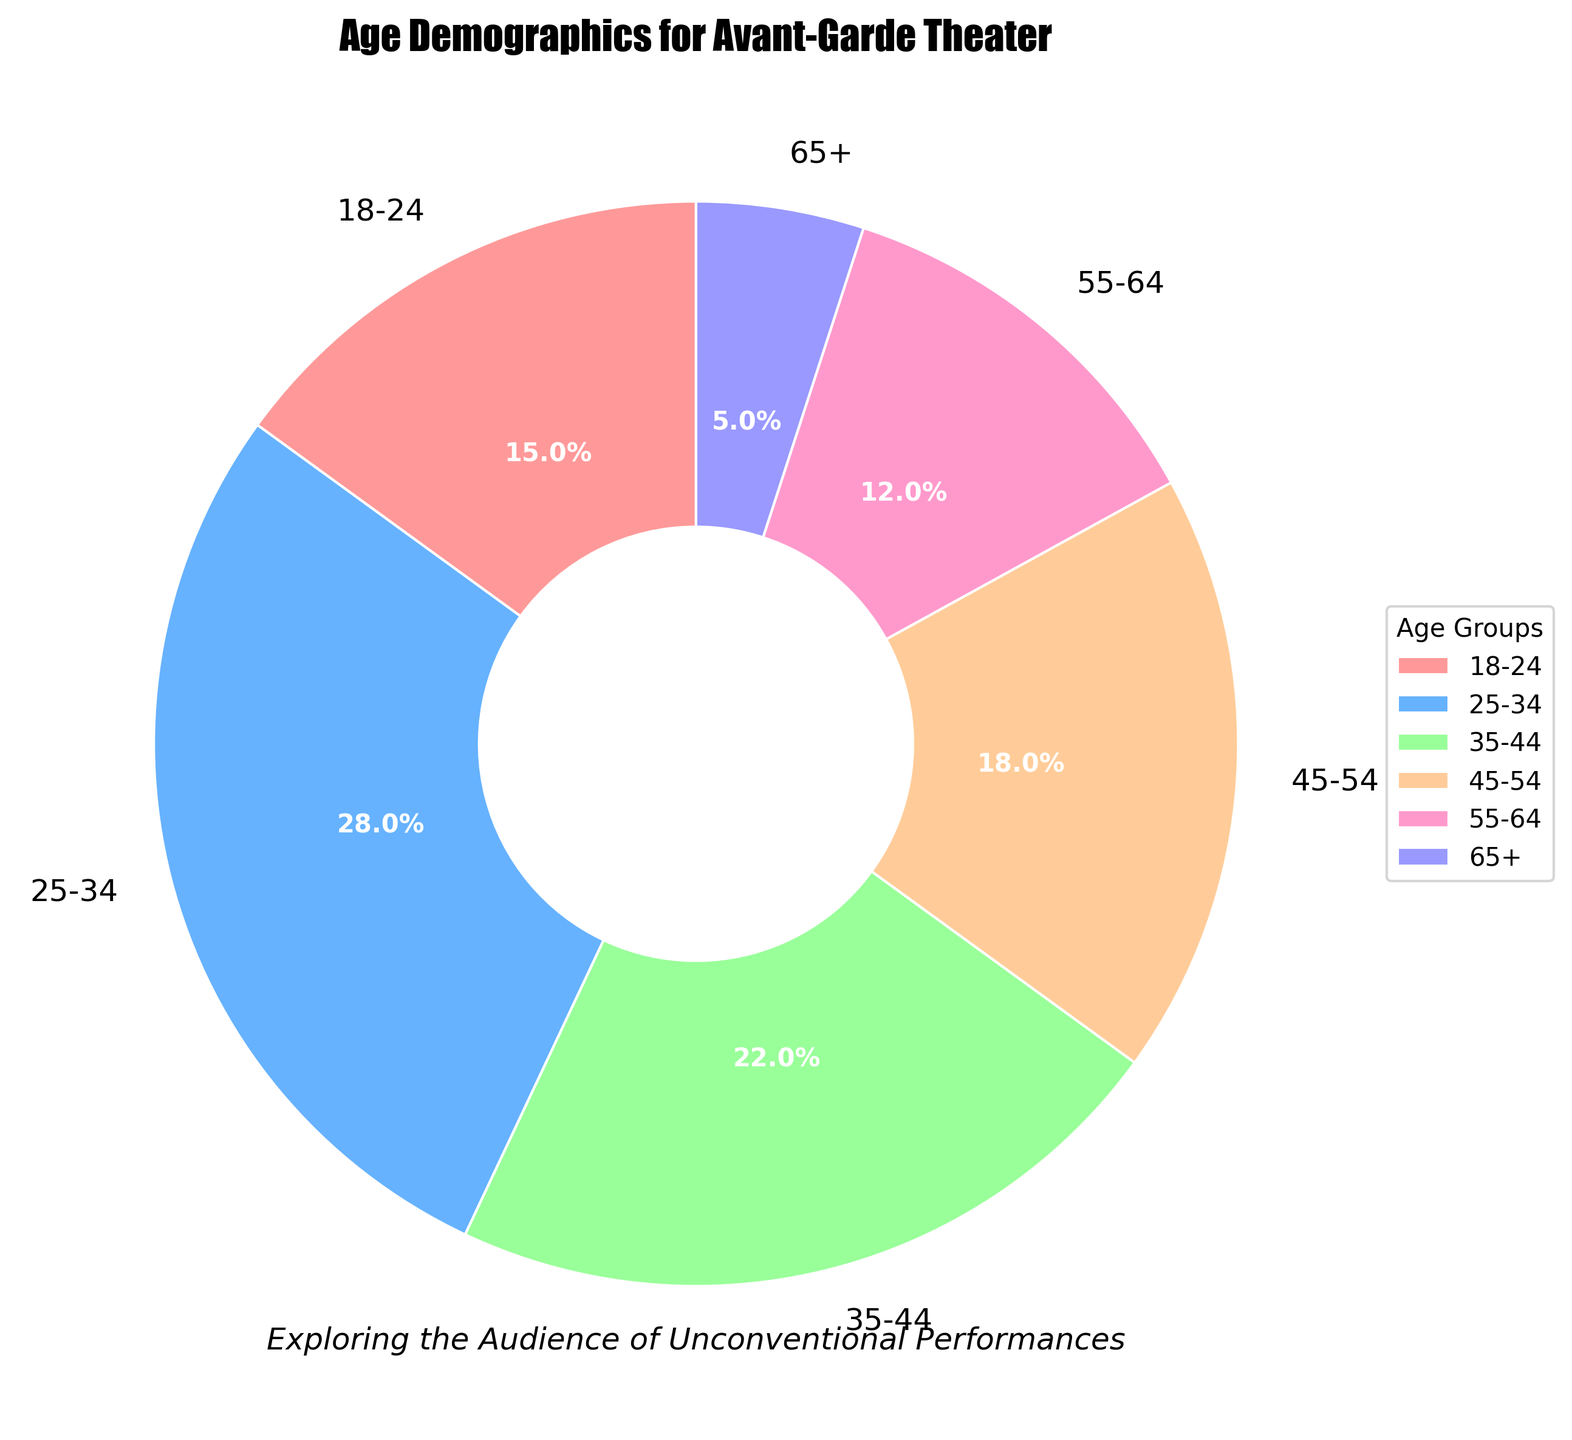What is the age group with the highest percentage of the audience? To determine the age group with the highest percentage, look for the largest segment in the pie chart. The segment labeled '25-34' occupies the largest portion of the pie.
Answer: 25-34 Which age group has almost half the percentage of the 25-34 age group? To find the age group with nearly half the percentage of the 25-34 group (which is 28%), find half of 28%, which is 14%. The age group 18-24 has 15%, which is the closest to half of 28%.
Answer: 18-24 How many age groups have a percentage less than 20% but more than 10%? Check each segment of the pie chart. Count the age groups with percentages between 10% and 20%. The groups 18-24 (15%), 45-54 (18%), and 55-64 (12%) fall in this range.
Answer: 3 What's the combined percentage of the audience under 35 years old? To find the combined percentage, sum the percentages of the age groups under 35 (18-24 and 25-34). Add 15% and 28%, which equals 43%.
Answer: 43% What percentage of the audience is above 54 years old? To find the percentage, add the percentages of the age groups 55-64 (12%) and 65+ (5%). The total is 12% + 5%, which equals 17%.
Answer: 17% Which age group is represented by the smallest segment of the pie chart? Look for the smallest segment in the pie chart. The segment labeled '65+' is the smallest.
Answer: 65+ How does the percentage of the 35-44 age group compare to the 55-64 age group? Compare the sizes of the segments labeled '35-44' and '55-64'. The 35-44 group has a percentage of 22%, while the 55-64 group has 12%. The 35-44 group is almost double the 55-64 group.
Answer: 35-44 is almost double 55-64 What is the visual attribute of the 45-54 age group in terms of its color? Identify the segment labeled '45-54', and note its color. The color is peach.
Answer: peach Are there any age groups with equal percentages? Review the segments' percentages to see if any are the same. All age group percentages are different.
Answer: No 